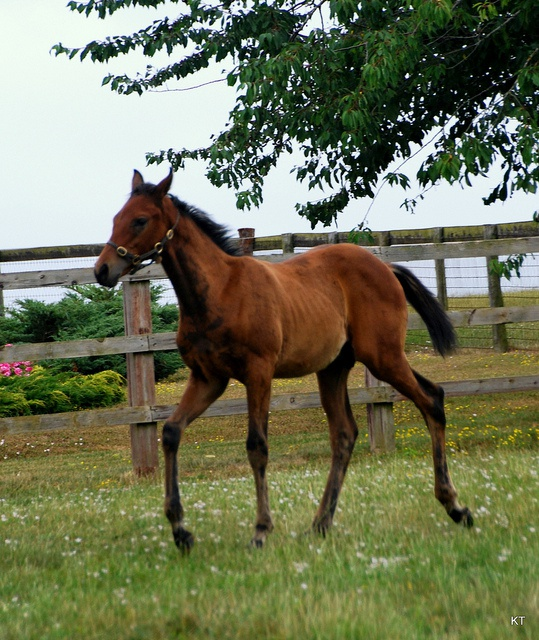Describe the objects in this image and their specific colors. I can see a horse in white, black, maroon, and brown tones in this image. 